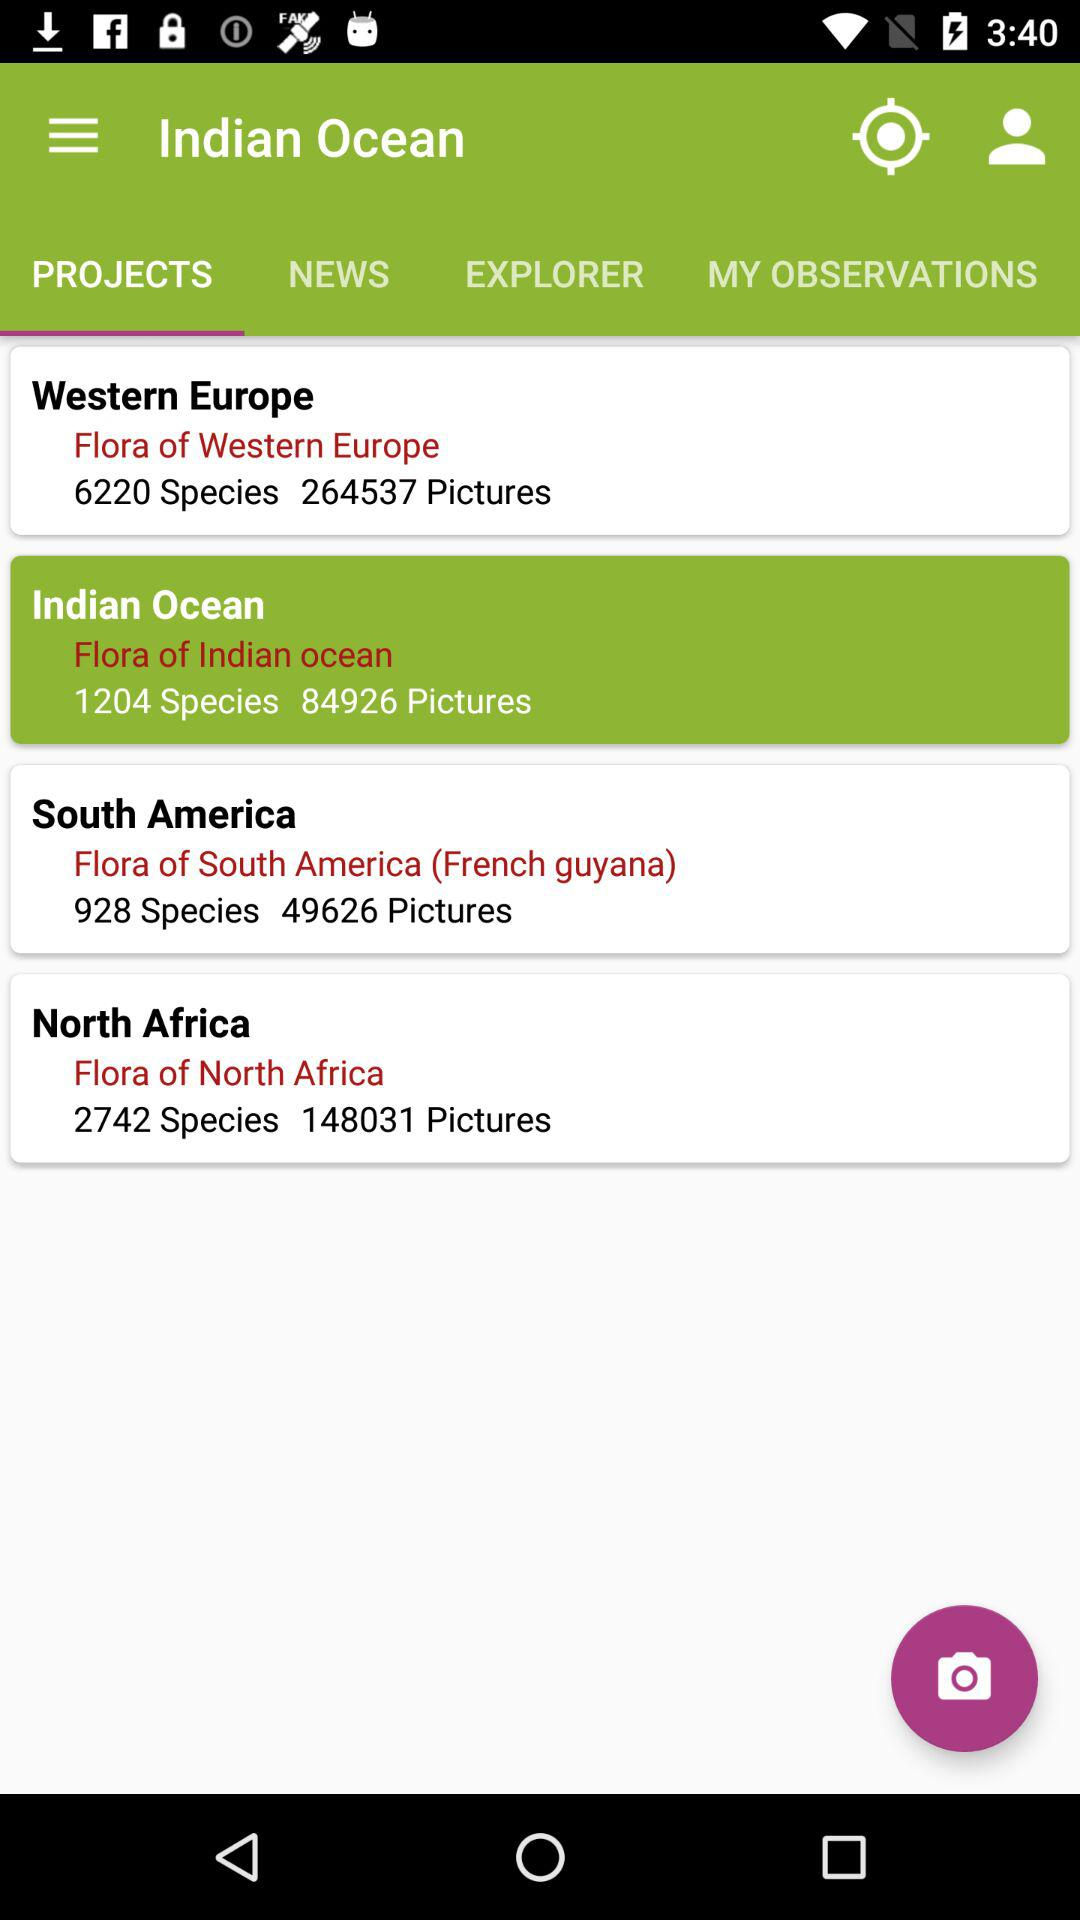How many species are there in North Africa? There are 2742 species in North Africa. 